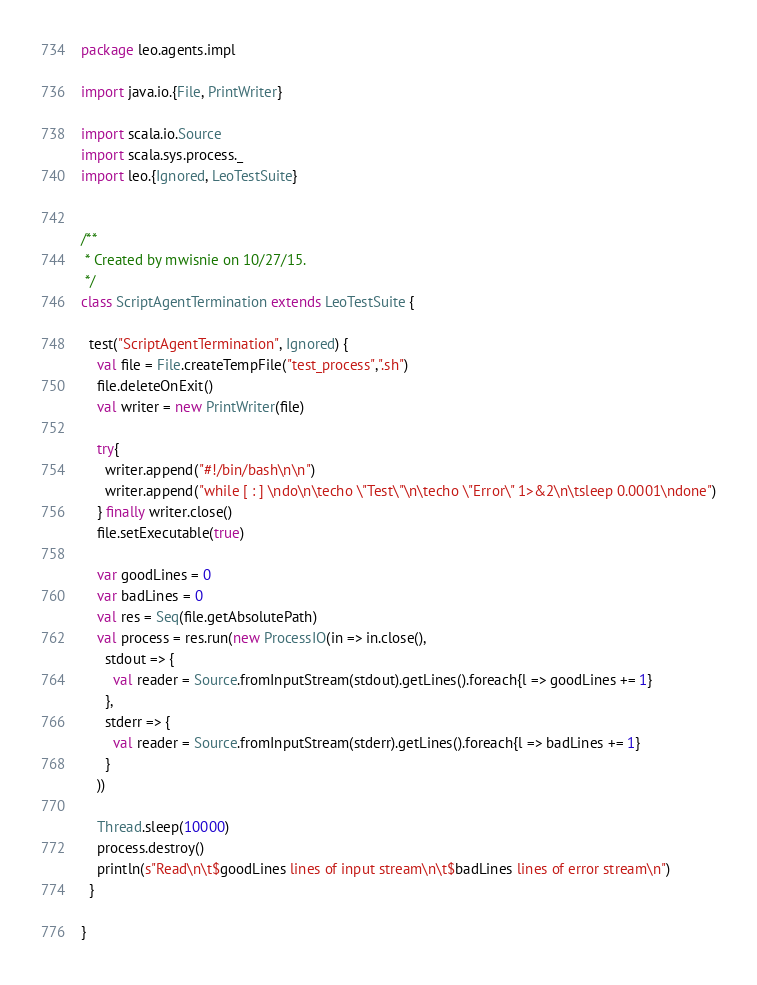<code> <loc_0><loc_0><loc_500><loc_500><_Scala_>package leo.agents.impl

import java.io.{File, PrintWriter}

import scala.io.Source
import scala.sys.process._
import leo.{Ignored, LeoTestSuite}


/**
 * Created by mwisnie on 10/27/15.
 */
class ScriptAgentTermination extends LeoTestSuite {

  test("ScriptAgentTermination", Ignored) {
    val file = File.createTempFile("test_process",".sh")
    file.deleteOnExit()
    val writer = new PrintWriter(file)

    try{
      writer.append("#!/bin/bash\n\n")
      writer.append("while [ : ] \ndo\n\techo \"Test\"\n\techo \"Error\" 1>&2\n\tsleep 0.0001\ndone")
    } finally writer.close()
    file.setExecutable(true)

    var goodLines = 0
    var badLines = 0
    val res = Seq(file.getAbsolutePath)
    val process = res.run(new ProcessIO(in => in.close(),
      stdout => {
        val reader = Source.fromInputStream(stdout).getLines().foreach{l => goodLines += 1}
      },
      stderr => {
        val reader = Source.fromInputStream(stderr).getLines().foreach{l => badLines += 1}
      }
    ))

    Thread.sleep(10000)
    process.destroy()
    println(s"Read\n\t$goodLines lines of input stream\n\t$badLines lines of error stream\n")
  }

}
</code> 